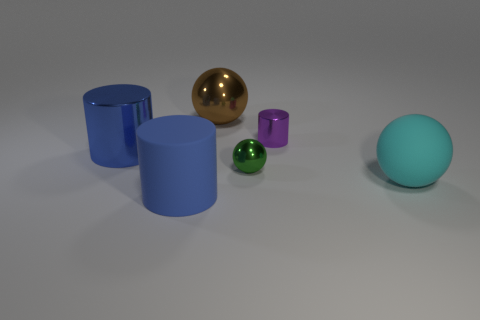Do the large matte cylinder and the large cylinder behind the large cyan rubber thing have the same color?
Offer a terse response. Yes. The metallic object that is the same color as the rubber cylinder is what shape?
Your answer should be very brief. Cylinder. How many tiny shiny things are the same color as the matte cylinder?
Your response must be concise. 0. There is a metallic cylinder that is to the right of the big brown ball; what size is it?
Offer a terse response. Small. What is the shape of the large shiny object to the left of the metal object that is behind the small metallic object to the right of the small green object?
Your answer should be very brief. Cylinder. The big object that is to the right of the blue matte cylinder and left of the large cyan sphere has what shape?
Give a very brief answer. Sphere. Are there any blue rubber cylinders that have the same size as the purple shiny cylinder?
Offer a terse response. No. Is the shape of the matte thing that is in front of the cyan ball the same as  the purple thing?
Keep it short and to the point. Yes. Is the blue metallic thing the same shape as the green metal object?
Provide a short and direct response. No. Is there a green metallic object that has the same shape as the small purple metallic thing?
Provide a short and direct response. No. 